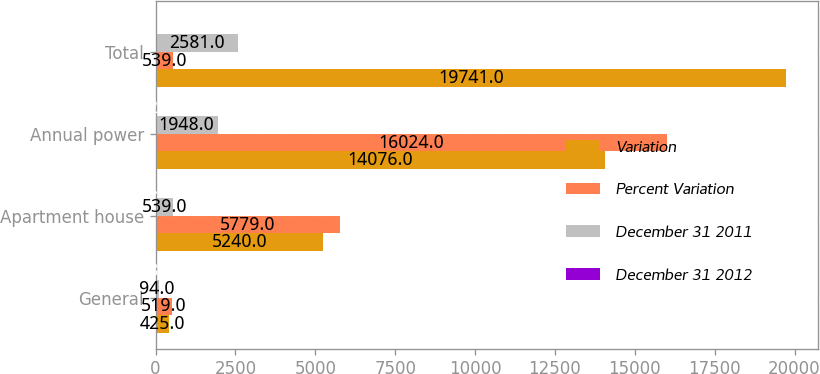<chart> <loc_0><loc_0><loc_500><loc_500><stacked_bar_chart><ecel><fcel>General<fcel>Apartment house<fcel>Annual power<fcel>Total<nl><fcel>Variation<fcel>425<fcel>5240<fcel>14076<fcel>19741<nl><fcel>Percent Variation<fcel>519<fcel>5779<fcel>16024<fcel>539<nl><fcel>December 31 2011<fcel>94<fcel>539<fcel>1948<fcel>2581<nl><fcel>December 31 2012<fcel>18.1<fcel>9.3<fcel>12.2<fcel>11.6<nl></chart> 